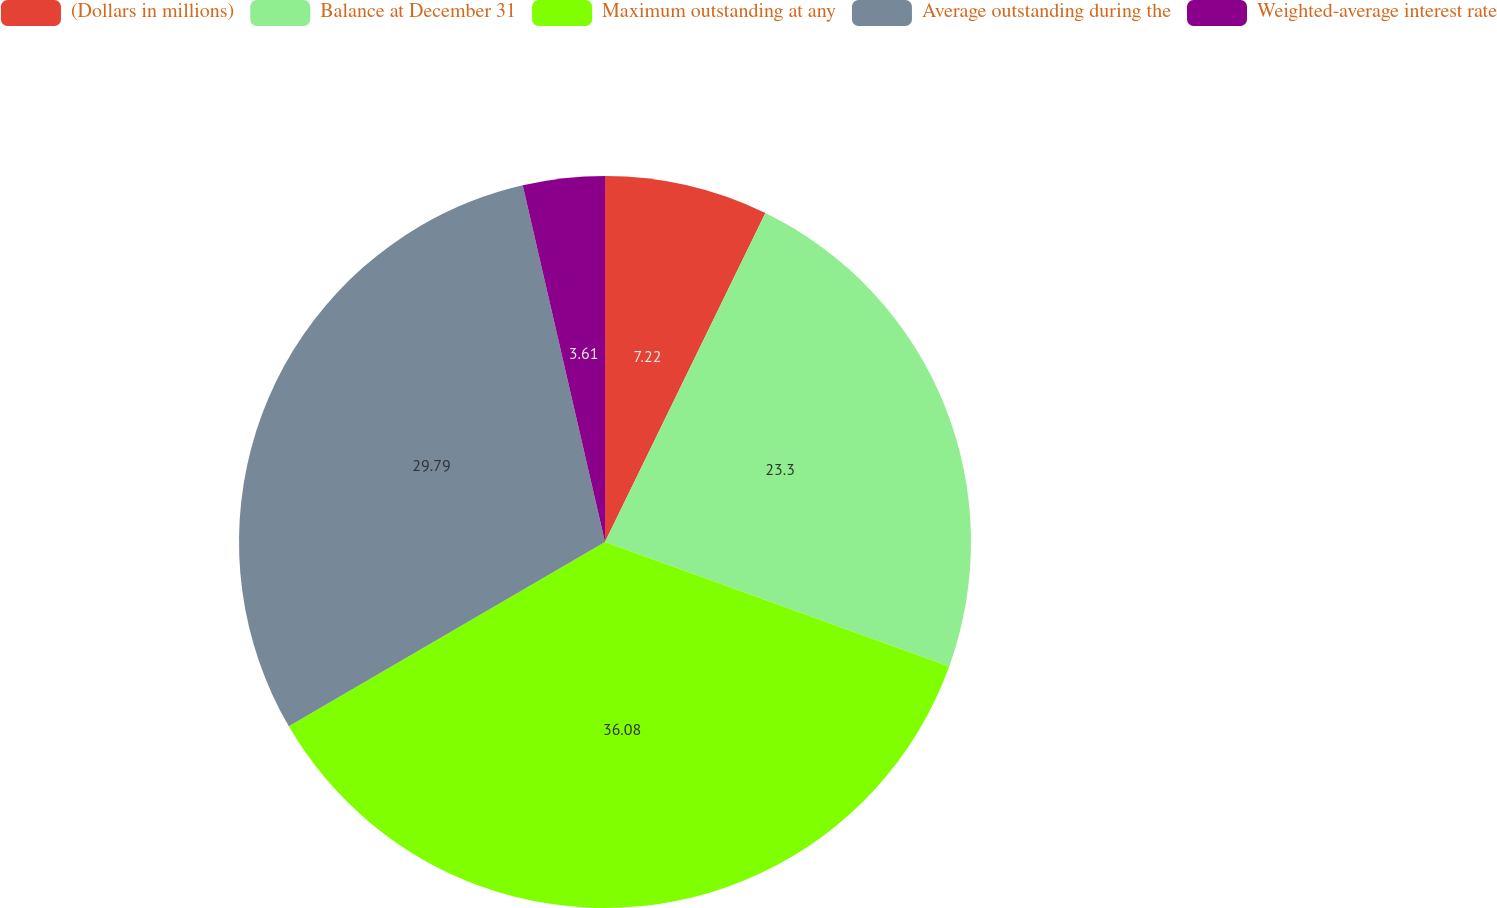Convert chart. <chart><loc_0><loc_0><loc_500><loc_500><pie_chart><fcel>(Dollars in millions)<fcel>Balance at December 31<fcel>Maximum outstanding at any<fcel>Average outstanding during the<fcel>Weighted-average interest rate<nl><fcel>7.22%<fcel>23.3%<fcel>36.08%<fcel>29.79%<fcel>3.61%<nl></chart> 